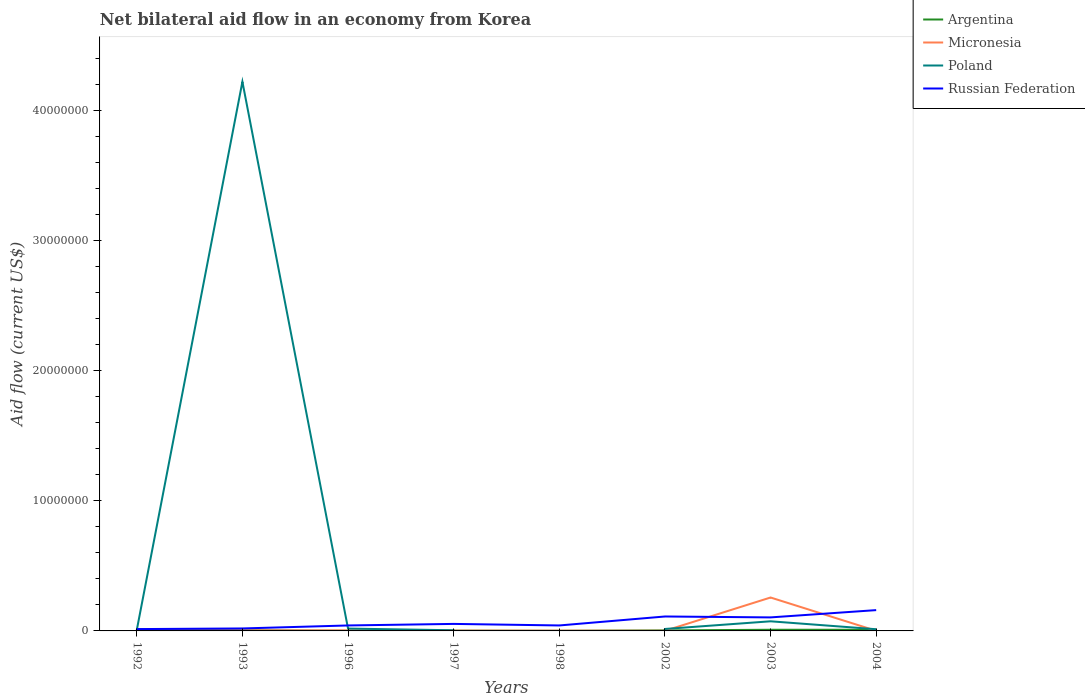How many different coloured lines are there?
Your answer should be very brief. 4. What is the total net bilateral aid flow in Poland in the graph?
Your response must be concise. 4.21e+07. What is the difference between the highest and the second highest net bilateral aid flow in Russian Federation?
Offer a terse response. 1.46e+06. What is the difference between the highest and the lowest net bilateral aid flow in Poland?
Provide a succinct answer. 1. What is the difference between two consecutive major ticks on the Y-axis?
Your answer should be compact. 1.00e+07. Where does the legend appear in the graph?
Give a very brief answer. Top right. What is the title of the graph?
Keep it short and to the point. Net bilateral aid flow in an economy from Korea. Does "Indonesia" appear as one of the legend labels in the graph?
Offer a very short reply. No. What is the Aid flow (current US$) of Argentina in 1992?
Provide a short and direct response. 1.20e+05. What is the Aid flow (current US$) of Micronesia in 1992?
Provide a succinct answer. 4.00e+04. What is the Aid flow (current US$) in Poland in 1992?
Keep it short and to the point. 7.00e+04. What is the Aid flow (current US$) in Russian Federation in 1992?
Offer a very short reply. 1.40e+05. What is the Aid flow (current US$) in Argentina in 1993?
Your answer should be compact. 5.00e+04. What is the Aid flow (current US$) of Poland in 1993?
Your answer should be very brief. 4.22e+07. What is the Aid flow (current US$) of Argentina in 1996?
Your answer should be compact. 10000. What is the Aid flow (current US$) in Micronesia in 1996?
Provide a short and direct response. 4.00e+04. What is the Aid flow (current US$) of Poland in 1996?
Ensure brevity in your answer.  1.80e+05. What is the Aid flow (current US$) of Russian Federation in 1996?
Provide a succinct answer. 4.20e+05. What is the Aid flow (current US$) in Argentina in 1997?
Your response must be concise. 2.00e+04. What is the Aid flow (current US$) of Micronesia in 1997?
Provide a short and direct response. 2.00e+04. What is the Aid flow (current US$) of Russian Federation in 1997?
Give a very brief answer. 5.40e+05. What is the Aid flow (current US$) of Argentina in 2002?
Provide a short and direct response. 4.00e+04. What is the Aid flow (current US$) in Micronesia in 2002?
Your response must be concise. 10000. What is the Aid flow (current US$) in Russian Federation in 2002?
Your answer should be very brief. 1.11e+06. What is the Aid flow (current US$) in Argentina in 2003?
Provide a short and direct response. 9.00e+04. What is the Aid flow (current US$) in Micronesia in 2003?
Your response must be concise. 2.57e+06. What is the Aid flow (current US$) in Poland in 2003?
Your answer should be very brief. 7.40e+05. What is the Aid flow (current US$) in Russian Federation in 2003?
Provide a short and direct response. 1.04e+06. What is the Aid flow (current US$) of Russian Federation in 2004?
Provide a succinct answer. 1.60e+06. Across all years, what is the maximum Aid flow (current US$) of Micronesia?
Offer a very short reply. 2.57e+06. Across all years, what is the maximum Aid flow (current US$) in Poland?
Your answer should be compact. 4.22e+07. Across all years, what is the maximum Aid flow (current US$) in Russian Federation?
Provide a short and direct response. 1.60e+06. Across all years, what is the minimum Aid flow (current US$) of Poland?
Keep it short and to the point. 0. What is the total Aid flow (current US$) of Argentina in the graph?
Provide a short and direct response. 4.30e+05. What is the total Aid flow (current US$) in Micronesia in the graph?
Offer a terse response. 2.75e+06. What is the total Aid flow (current US$) of Poland in the graph?
Provide a succinct answer. 4.36e+07. What is the total Aid flow (current US$) of Russian Federation in the graph?
Your answer should be compact. 5.46e+06. What is the difference between the Aid flow (current US$) of Argentina in 1992 and that in 1993?
Provide a short and direct response. 7.00e+04. What is the difference between the Aid flow (current US$) in Micronesia in 1992 and that in 1993?
Your answer should be very brief. 0. What is the difference between the Aid flow (current US$) in Poland in 1992 and that in 1993?
Make the answer very short. -4.22e+07. What is the difference between the Aid flow (current US$) in Russian Federation in 1992 and that in 1993?
Offer a terse response. -5.00e+04. What is the difference between the Aid flow (current US$) in Poland in 1992 and that in 1996?
Offer a very short reply. -1.10e+05. What is the difference between the Aid flow (current US$) of Russian Federation in 1992 and that in 1996?
Offer a very short reply. -2.80e+05. What is the difference between the Aid flow (current US$) in Argentina in 1992 and that in 1997?
Offer a very short reply. 1.00e+05. What is the difference between the Aid flow (current US$) in Poland in 1992 and that in 1997?
Offer a terse response. 2.00e+04. What is the difference between the Aid flow (current US$) in Russian Federation in 1992 and that in 1997?
Ensure brevity in your answer.  -4.00e+05. What is the difference between the Aid flow (current US$) in Argentina in 1992 and that in 1998?
Ensure brevity in your answer.  1.10e+05. What is the difference between the Aid flow (current US$) of Micronesia in 1992 and that in 1998?
Offer a very short reply. 2.00e+04. What is the difference between the Aid flow (current US$) of Russian Federation in 1992 and that in 1998?
Your answer should be compact. -2.80e+05. What is the difference between the Aid flow (current US$) in Micronesia in 1992 and that in 2002?
Provide a short and direct response. 3.00e+04. What is the difference between the Aid flow (current US$) of Russian Federation in 1992 and that in 2002?
Your answer should be compact. -9.70e+05. What is the difference between the Aid flow (current US$) of Argentina in 1992 and that in 2003?
Provide a short and direct response. 3.00e+04. What is the difference between the Aid flow (current US$) in Micronesia in 1992 and that in 2003?
Your answer should be very brief. -2.53e+06. What is the difference between the Aid flow (current US$) in Poland in 1992 and that in 2003?
Offer a very short reply. -6.70e+05. What is the difference between the Aid flow (current US$) in Russian Federation in 1992 and that in 2003?
Provide a succinct answer. -9.00e+05. What is the difference between the Aid flow (current US$) of Argentina in 1992 and that in 2004?
Make the answer very short. 3.00e+04. What is the difference between the Aid flow (current US$) of Russian Federation in 1992 and that in 2004?
Offer a very short reply. -1.46e+06. What is the difference between the Aid flow (current US$) of Argentina in 1993 and that in 1996?
Offer a very short reply. 4.00e+04. What is the difference between the Aid flow (current US$) of Poland in 1993 and that in 1996?
Give a very brief answer. 4.21e+07. What is the difference between the Aid flow (current US$) of Argentina in 1993 and that in 1997?
Ensure brevity in your answer.  3.00e+04. What is the difference between the Aid flow (current US$) of Micronesia in 1993 and that in 1997?
Offer a very short reply. 2.00e+04. What is the difference between the Aid flow (current US$) in Poland in 1993 and that in 1997?
Your answer should be very brief. 4.22e+07. What is the difference between the Aid flow (current US$) in Russian Federation in 1993 and that in 1997?
Provide a short and direct response. -3.50e+05. What is the difference between the Aid flow (current US$) of Argentina in 1993 and that in 1998?
Give a very brief answer. 4.00e+04. What is the difference between the Aid flow (current US$) of Russian Federation in 1993 and that in 1998?
Provide a succinct answer. -2.30e+05. What is the difference between the Aid flow (current US$) of Poland in 1993 and that in 2002?
Make the answer very short. 4.21e+07. What is the difference between the Aid flow (current US$) in Russian Federation in 1993 and that in 2002?
Your answer should be very brief. -9.20e+05. What is the difference between the Aid flow (current US$) of Micronesia in 1993 and that in 2003?
Provide a succinct answer. -2.53e+06. What is the difference between the Aid flow (current US$) of Poland in 1993 and that in 2003?
Provide a short and direct response. 4.15e+07. What is the difference between the Aid flow (current US$) in Russian Federation in 1993 and that in 2003?
Offer a terse response. -8.50e+05. What is the difference between the Aid flow (current US$) of Micronesia in 1993 and that in 2004?
Give a very brief answer. 3.00e+04. What is the difference between the Aid flow (current US$) of Poland in 1993 and that in 2004?
Offer a very short reply. 4.21e+07. What is the difference between the Aid flow (current US$) of Russian Federation in 1993 and that in 2004?
Give a very brief answer. -1.41e+06. What is the difference between the Aid flow (current US$) in Micronesia in 1996 and that in 1997?
Ensure brevity in your answer.  2.00e+04. What is the difference between the Aid flow (current US$) of Poland in 1996 and that in 1997?
Your response must be concise. 1.30e+05. What is the difference between the Aid flow (current US$) of Russian Federation in 1996 and that in 1998?
Offer a very short reply. 0. What is the difference between the Aid flow (current US$) in Poland in 1996 and that in 2002?
Provide a succinct answer. 3.00e+04. What is the difference between the Aid flow (current US$) in Russian Federation in 1996 and that in 2002?
Your answer should be very brief. -6.90e+05. What is the difference between the Aid flow (current US$) of Micronesia in 1996 and that in 2003?
Your answer should be compact. -2.53e+06. What is the difference between the Aid flow (current US$) of Poland in 1996 and that in 2003?
Offer a terse response. -5.60e+05. What is the difference between the Aid flow (current US$) of Russian Federation in 1996 and that in 2003?
Make the answer very short. -6.20e+05. What is the difference between the Aid flow (current US$) of Russian Federation in 1996 and that in 2004?
Your answer should be compact. -1.18e+06. What is the difference between the Aid flow (current US$) of Russian Federation in 1997 and that in 2002?
Make the answer very short. -5.70e+05. What is the difference between the Aid flow (current US$) in Argentina in 1997 and that in 2003?
Your answer should be very brief. -7.00e+04. What is the difference between the Aid flow (current US$) of Micronesia in 1997 and that in 2003?
Offer a terse response. -2.55e+06. What is the difference between the Aid flow (current US$) of Poland in 1997 and that in 2003?
Provide a succinct answer. -6.90e+05. What is the difference between the Aid flow (current US$) of Russian Federation in 1997 and that in 2003?
Your answer should be very brief. -5.00e+05. What is the difference between the Aid flow (current US$) of Argentina in 1997 and that in 2004?
Your answer should be very brief. -7.00e+04. What is the difference between the Aid flow (current US$) of Micronesia in 1997 and that in 2004?
Ensure brevity in your answer.  10000. What is the difference between the Aid flow (current US$) in Russian Federation in 1997 and that in 2004?
Give a very brief answer. -1.06e+06. What is the difference between the Aid flow (current US$) in Russian Federation in 1998 and that in 2002?
Give a very brief answer. -6.90e+05. What is the difference between the Aid flow (current US$) of Argentina in 1998 and that in 2003?
Offer a terse response. -8.00e+04. What is the difference between the Aid flow (current US$) of Micronesia in 1998 and that in 2003?
Give a very brief answer. -2.55e+06. What is the difference between the Aid flow (current US$) in Russian Federation in 1998 and that in 2003?
Provide a short and direct response. -6.20e+05. What is the difference between the Aid flow (current US$) in Argentina in 1998 and that in 2004?
Offer a terse response. -8.00e+04. What is the difference between the Aid flow (current US$) in Russian Federation in 1998 and that in 2004?
Your answer should be compact. -1.18e+06. What is the difference between the Aid flow (current US$) in Micronesia in 2002 and that in 2003?
Provide a short and direct response. -2.56e+06. What is the difference between the Aid flow (current US$) in Poland in 2002 and that in 2003?
Make the answer very short. -5.90e+05. What is the difference between the Aid flow (current US$) of Russian Federation in 2002 and that in 2003?
Provide a succinct answer. 7.00e+04. What is the difference between the Aid flow (current US$) in Russian Federation in 2002 and that in 2004?
Your answer should be compact. -4.90e+05. What is the difference between the Aid flow (current US$) of Argentina in 2003 and that in 2004?
Your answer should be very brief. 0. What is the difference between the Aid flow (current US$) of Micronesia in 2003 and that in 2004?
Your answer should be compact. 2.56e+06. What is the difference between the Aid flow (current US$) of Russian Federation in 2003 and that in 2004?
Keep it short and to the point. -5.60e+05. What is the difference between the Aid flow (current US$) of Argentina in 1992 and the Aid flow (current US$) of Micronesia in 1993?
Your response must be concise. 8.00e+04. What is the difference between the Aid flow (current US$) of Argentina in 1992 and the Aid flow (current US$) of Poland in 1993?
Provide a succinct answer. -4.21e+07. What is the difference between the Aid flow (current US$) of Micronesia in 1992 and the Aid flow (current US$) of Poland in 1993?
Keep it short and to the point. -4.22e+07. What is the difference between the Aid flow (current US$) in Micronesia in 1992 and the Aid flow (current US$) in Russian Federation in 1993?
Make the answer very short. -1.50e+05. What is the difference between the Aid flow (current US$) of Poland in 1992 and the Aid flow (current US$) of Russian Federation in 1993?
Your response must be concise. -1.20e+05. What is the difference between the Aid flow (current US$) of Argentina in 1992 and the Aid flow (current US$) of Micronesia in 1996?
Offer a very short reply. 8.00e+04. What is the difference between the Aid flow (current US$) in Argentina in 1992 and the Aid flow (current US$) in Poland in 1996?
Provide a succinct answer. -6.00e+04. What is the difference between the Aid flow (current US$) in Argentina in 1992 and the Aid flow (current US$) in Russian Federation in 1996?
Make the answer very short. -3.00e+05. What is the difference between the Aid flow (current US$) in Micronesia in 1992 and the Aid flow (current US$) in Poland in 1996?
Provide a short and direct response. -1.40e+05. What is the difference between the Aid flow (current US$) of Micronesia in 1992 and the Aid flow (current US$) of Russian Federation in 1996?
Your answer should be very brief. -3.80e+05. What is the difference between the Aid flow (current US$) in Poland in 1992 and the Aid flow (current US$) in Russian Federation in 1996?
Provide a succinct answer. -3.50e+05. What is the difference between the Aid flow (current US$) in Argentina in 1992 and the Aid flow (current US$) in Micronesia in 1997?
Keep it short and to the point. 1.00e+05. What is the difference between the Aid flow (current US$) in Argentina in 1992 and the Aid flow (current US$) in Russian Federation in 1997?
Offer a very short reply. -4.20e+05. What is the difference between the Aid flow (current US$) in Micronesia in 1992 and the Aid flow (current US$) in Poland in 1997?
Your answer should be compact. -10000. What is the difference between the Aid flow (current US$) in Micronesia in 1992 and the Aid flow (current US$) in Russian Federation in 1997?
Your response must be concise. -5.00e+05. What is the difference between the Aid flow (current US$) of Poland in 1992 and the Aid flow (current US$) of Russian Federation in 1997?
Make the answer very short. -4.70e+05. What is the difference between the Aid flow (current US$) in Argentina in 1992 and the Aid flow (current US$) in Micronesia in 1998?
Offer a very short reply. 1.00e+05. What is the difference between the Aid flow (current US$) in Argentina in 1992 and the Aid flow (current US$) in Russian Federation in 1998?
Your answer should be very brief. -3.00e+05. What is the difference between the Aid flow (current US$) in Micronesia in 1992 and the Aid flow (current US$) in Russian Federation in 1998?
Give a very brief answer. -3.80e+05. What is the difference between the Aid flow (current US$) of Poland in 1992 and the Aid flow (current US$) of Russian Federation in 1998?
Provide a short and direct response. -3.50e+05. What is the difference between the Aid flow (current US$) of Argentina in 1992 and the Aid flow (current US$) of Poland in 2002?
Ensure brevity in your answer.  -3.00e+04. What is the difference between the Aid flow (current US$) of Argentina in 1992 and the Aid flow (current US$) of Russian Federation in 2002?
Provide a succinct answer. -9.90e+05. What is the difference between the Aid flow (current US$) of Micronesia in 1992 and the Aid flow (current US$) of Russian Federation in 2002?
Keep it short and to the point. -1.07e+06. What is the difference between the Aid flow (current US$) in Poland in 1992 and the Aid flow (current US$) in Russian Federation in 2002?
Your answer should be very brief. -1.04e+06. What is the difference between the Aid flow (current US$) in Argentina in 1992 and the Aid flow (current US$) in Micronesia in 2003?
Give a very brief answer. -2.45e+06. What is the difference between the Aid flow (current US$) of Argentina in 1992 and the Aid flow (current US$) of Poland in 2003?
Your answer should be very brief. -6.20e+05. What is the difference between the Aid flow (current US$) in Argentina in 1992 and the Aid flow (current US$) in Russian Federation in 2003?
Your response must be concise. -9.20e+05. What is the difference between the Aid flow (current US$) in Micronesia in 1992 and the Aid flow (current US$) in Poland in 2003?
Make the answer very short. -7.00e+05. What is the difference between the Aid flow (current US$) of Poland in 1992 and the Aid flow (current US$) of Russian Federation in 2003?
Provide a short and direct response. -9.70e+05. What is the difference between the Aid flow (current US$) in Argentina in 1992 and the Aid flow (current US$) in Micronesia in 2004?
Your response must be concise. 1.10e+05. What is the difference between the Aid flow (current US$) of Argentina in 1992 and the Aid flow (current US$) of Poland in 2004?
Keep it short and to the point. -10000. What is the difference between the Aid flow (current US$) of Argentina in 1992 and the Aid flow (current US$) of Russian Federation in 2004?
Offer a very short reply. -1.48e+06. What is the difference between the Aid flow (current US$) of Micronesia in 1992 and the Aid flow (current US$) of Poland in 2004?
Your response must be concise. -9.00e+04. What is the difference between the Aid flow (current US$) in Micronesia in 1992 and the Aid flow (current US$) in Russian Federation in 2004?
Your answer should be compact. -1.56e+06. What is the difference between the Aid flow (current US$) of Poland in 1992 and the Aid flow (current US$) of Russian Federation in 2004?
Ensure brevity in your answer.  -1.53e+06. What is the difference between the Aid flow (current US$) in Argentina in 1993 and the Aid flow (current US$) in Poland in 1996?
Offer a very short reply. -1.30e+05. What is the difference between the Aid flow (current US$) in Argentina in 1993 and the Aid flow (current US$) in Russian Federation in 1996?
Your answer should be very brief. -3.70e+05. What is the difference between the Aid flow (current US$) of Micronesia in 1993 and the Aid flow (current US$) of Russian Federation in 1996?
Provide a succinct answer. -3.80e+05. What is the difference between the Aid flow (current US$) in Poland in 1993 and the Aid flow (current US$) in Russian Federation in 1996?
Offer a very short reply. 4.18e+07. What is the difference between the Aid flow (current US$) of Argentina in 1993 and the Aid flow (current US$) of Poland in 1997?
Make the answer very short. 0. What is the difference between the Aid flow (current US$) of Argentina in 1993 and the Aid flow (current US$) of Russian Federation in 1997?
Your response must be concise. -4.90e+05. What is the difference between the Aid flow (current US$) of Micronesia in 1993 and the Aid flow (current US$) of Poland in 1997?
Provide a short and direct response. -10000. What is the difference between the Aid flow (current US$) of Micronesia in 1993 and the Aid flow (current US$) of Russian Federation in 1997?
Make the answer very short. -5.00e+05. What is the difference between the Aid flow (current US$) in Poland in 1993 and the Aid flow (current US$) in Russian Federation in 1997?
Offer a terse response. 4.17e+07. What is the difference between the Aid flow (current US$) in Argentina in 1993 and the Aid flow (current US$) in Russian Federation in 1998?
Keep it short and to the point. -3.70e+05. What is the difference between the Aid flow (current US$) in Micronesia in 1993 and the Aid flow (current US$) in Russian Federation in 1998?
Keep it short and to the point. -3.80e+05. What is the difference between the Aid flow (current US$) in Poland in 1993 and the Aid flow (current US$) in Russian Federation in 1998?
Your response must be concise. 4.18e+07. What is the difference between the Aid flow (current US$) of Argentina in 1993 and the Aid flow (current US$) of Micronesia in 2002?
Give a very brief answer. 4.00e+04. What is the difference between the Aid flow (current US$) in Argentina in 1993 and the Aid flow (current US$) in Russian Federation in 2002?
Ensure brevity in your answer.  -1.06e+06. What is the difference between the Aid flow (current US$) of Micronesia in 1993 and the Aid flow (current US$) of Russian Federation in 2002?
Keep it short and to the point. -1.07e+06. What is the difference between the Aid flow (current US$) in Poland in 1993 and the Aid flow (current US$) in Russian Federation in 2002?
Ensure brevity in your answer.  4.11e+07. What is the difference between the Aid flow (current US$) in Argentina in 1993 and the Aid flow (current US$) in Micronesia in 2003?
Your answer should be compact. -2.52e+06. What is the difference between the Aid flow (current US$) in Argentina in 1993 and the Aid flow (current US$) in Poland in 2003?
Offer a very short reply. -6.90e+05. What is the difference between the Aid flow (current US$) in Argentina in 1993 and the Aid flow (current US$) in Russian Federation in 2003?
Provide a short and direct response. -9.90e+05. What is the difference between the Aid flow (current US$) in Micronesia in 1993 and the Aid flow (current US$) in Poland in 2003?
Provide a short and direct response. -7.00e+05. What is the difference between the Aid flow (current US$) of Poland in 1993 and the Aid flow (current US$) of Russian Federation in 2003?
Your answer should be very brief. 4.12e+07. What is the difference between the Aid flow (current US$) of Argentina in 1993 and the Aid flow (current US$) of Micronesia in 2004?
Ensure brevity in your answer.  4.00e+04. What is the difference between the Aid flow (current US$) in Argentina in 1993 and the Aid flow (current US$) in Russian Federation in 2004?
Offer a very short reply. -1.55e+06. What is the difference between the Aid flow (current US$) of Micronesia in 1993 and the Aid flow (current US$) of Poland in 2004?
Provide a short and direct response. -9.00e+04. What is the difference between the Aid flow (current US$) of Micronesia in 1993 and the Aid flow (current US$) of Russian Federation in 2004?
Keep it short and to the point. -1.56e+06. What is the difference between the Aid flow (current US$) of Poland in 1993 and the Aid flow (current US$) of Russian Federation in 2004?
Make the answer very short. 4.06e+07. What is the difference between the Aid flow (current US$) in Argentina in 1996 and the Aid flow (current US$) in Micronesia in 1997?
Make the answer very short. -10000. What is the difference between the Aid flow (current US$) in Argentina in 1996 and the Aid flow (current US$) in Russian Federation in 1997?
Ensure brevity in your answer.  -5.30e+05. What is the difference between the Aid flow (current US$) in Micronesia in 1996 and the Aid flow (current US$) in Russian Federation in 1997?
Your response must be concise. -5.00e+05. What is the difference between the Aid flow (current US$) in Poland in 1996 and the Aid flow (current US$) in Russian Federation in 1997?
Provide a succinct answer. -3.60e+05. What is the difference between the Aid flow (current US$) in Argentina in 1996 and the Aid flow (current US$) in Micronesia in 1998?
Your answer should be compact. -10000. What is the difference between the Aid flow (current US$) in Argentina in 1996 and the Aid flow (current US$) in Russian Federation in 1998?
Provide a succinct answer. -4.10e+05. What is the difference between the Aid flow (current US$) in Micronesia in 1996 and the Aid flow (current US$) in Russian Federation in 1998?
Your answer should be very brief. -3.80e+05. What is the difference between the Aid flow (current US$) in Poland in 1996 and the Aid flow (current US$) in Russian Federation in 1998?
Your response must be concise. -2.40e+05. What is the difference between the Aid flow (current US$) of Argentina in 1996 and the Aid flow (current US$) of Micronesia in 2002?
Make the answer very short. 0. What is the difference between the Aid flow (current US$) in Argentina in 1996 and the Aid flow (current US$) in Russian Federation in 2002?
Your response must be concise. -1.10e+06. What is the difference between the Aid flow (current US$) in Micronesia in 1996 and the Aid flow (current US$) in Russian Federation in 2002?
Provide a succinct answer. -1.07e+06. What is the difference between the Aid flow (current US$) of Poland in 1996 and the Aid flow (current US$) of Russian Federation in 2002?
Give a very brief answer. -9.30e+05. What is the difference between the Aid flow (current US$) of Argentina in 1996 and the Aid flow (current US$) of Micronesia in 2003?
Your response must be concise. -2.56e+06. What is the difference between the Aid flow (current US$) in Argentina in 1996 and the Aid flow (current US$) in Poland in 2003?
Your answer should be very brief. -7.30e+05. What is the difference between the Aid flow (current US$) in Argentina in 1996 and the Aid flow (current US$) in Russian Federation in 2003?
Your answer should be compact. -1.03e+06. What is the difference between the Aid flow (current US$) of Micronesia in 1996 and the Aid flow (current US$) of Poland in 2003?
Offer a very short reply. -7.00e+05. What is the difference between the Aid flow (current US$) of Poland in 1996 and the Aid flow (current US$) of Russian Federation in 2003?
Give a very brief answer. -8.60e+05. What is the difference between the Aid flow (current US$) of Argentina in 1996 and the Aid flow (current US$) of Russian Federation in 2004?
Ensure brevity in your answer.  -1.59e+06. What is the difference between the Aid flow (current US$) in Micronesia in 1996 and the Aid flow (current US$) in Poland in 2004?
Provide a succinct answer. -9.00e+04. What is the difference between the Aid flow (current US$) in Micronesia in 1996 and the Aid flow (current US$) in Russian Federation in 2004?
Provide a short and direct response. -1.56e+06. What is the difference between the Aid flow (current US$) of Poland in 1996 and the Aid flow (current US$) of Russian Federation in 2004?
Your response must be concise. -1.42e+06. What is the difference between the Aid flow (current US$) of Argentina in 1997 and the Aid flow (current US$) of Micronesia in 1998?
Ensure brevity in your answer.  0. What is the difference between the Aid flow (current US$) in Argentina in 1997 and the Aid flow (current US$) in Russian Federation in 1998?
Your response must be concise. -4.00e+05. What is the difference between the Aid flow (current US$) in Micronesia in 1997 and the Aid flow (current US$) in Russian Federation in 1998?
Ensure brevity in your answer.  -4.00e+05. What is the difference between the Aid flow (current US$) of Poland in 1997 and the Aid flow (current US$) of Russian Federation in 1998?
Keep it short and to the point. -3.70e+05. What is the difference between the Aid flow (current US$) of Argentina in 1997 and the Aid flow (current US$) of Micronesia in 2002?
Ensure brevity in your answer.  10000. What is the difference between the Aid flow (current US$) in Argentina in 1997 and the Aid flow (current US$) in Poland in 2002?
Keep it short and to the point. -1.30e+05. What is the difference between the Aid flow (current US$) in Argentina in 1997 and the Aid flow (current US$) in Russian Federation in 2002?
Offer a terse response. -1.09e+06. What is the difference between the Aid flow (current US$) in Micronesia in 1997 and the Aid flow (current US$) in Russian Federation in 2002?
Your response must be concise. -1.09e+06. What is the difference between the Aid flow (current US$) of Poland in 1997 and the Aid flow (current US$) of Russian Federation in 2002?
Keep it short and to the point. -1.06e+06. What is the difference between the Aid flow (current US$) in Argentina in 1997 and the Aid flow (current US$) in Micronesia in 2003?
Your answer should be very brief. -2.55e+06. What is the difference between the Aid flow (current US$) of Argentina in 1997 and the Aid flow (current US$) of Poland in 2003?
Offer a terse response. -7.20e+05. What is the difference between the Aid flow (current US$) of Argentina in 1997 and the Aid flow (current US$) of Russian Federation in 2003?
Your response must be concise. -1.02e+06. What is the difference between the Aid flow (current US$) of Micronesia in 1997 and the Aid flow (current US$) of Poland in 2003?
Offer a very short reply. -7.20e+05. What is the difference between the Aid flow (current US$) in Micronesia in 1997 and the Aid flow (current US$) in Russian Federation in 2003?
Ensure brevity in your answer.  -1.02e+06. What is the difference between the Aid flow (current US$) in Poland in 1997 and the Aid flow (current US$) in Russian Federation in 2003?
Provide a succinct answer. -9.90e+05. What is the difference between the Aid flow (current US$) in Argentina in 1997 and the Aid flow (current US$) in Russian Federation in 2004?
Offer a very short reply. -1.58e+06. What is the difference between the Aid flow (current US$) of Micronesia in 1997 and the Aid flow (current US$) of Russian Federation in 2004?
Provide a succinct answer. -1.58e+06. What is the difference between the Aid flow (current US$) of Poland in 1997 and the Aid flow (current US$) of Russian Federation in 2004?
Give a very brief answer. -1.55e+06. What is the difference between the Aid flow (current US$) in Argentina in 1998 and the Aid flow (current US$) in Poland in 2002?
Your answer should be very brief. -1.40e+05. What is the difference between the Aid flow (current US$) in Argentina in 1998 and the Aid flow (current US$) in Russian Federation in 2002?
Give a very brief answer. -1.10e+06. What is the difference between the Aid flow (current US$) of Micronesia in 1998 and the Aid flow (current US$) of Poland in 2002?
Provide a succinct answer. -1.30e+05. What is the difference between the Aid flow (current US$) of Micronesia in 1998 and the Aid flow (current US$) of Russian Federation in 2002?
Your answer should be compact. -1.09e+06. What is the difference between the Aid flow (current US$) in Argentina in 1998 and the Aid flow (current US$) in Micronesia in 2003?
Ensure brevity in your answer.  -2.56e+06. What is the difference between the Aid flow (current US$) of Argentina in 1998 and the Aid flow (current US$) of Poland in 2003?
Make the answer very short. -7.30e+05. What is the difference between the Aid flow (current US$) of Argentina in 1998 and the Aid flow (current US$) of Russian Federation in 2003?
Provide a succinct answer. -1.03e+06. What is the difference between the Aid flow (current US$) in Micronesia in 1998 and the Aid flow (current US$) in Poland in 2003?
Offer a very short reply. -7.20e+05. What is the difference between the Aid flow (current US$) in Micronesia in 1998 and the Aid flow (current US$) in Russian Federation in 2003?
Give a very brief answer. -1.02e+06. What is the difference between the Aid flow (current US$) in Argentina in 1998 and the Aid flow (current US$) in Russian Federation in 2004?
Offer a terse response. -1.59e+06. What is the difference between the Aid flow (current US$) in Micronesia in 1998 and the Aid flow (current US$) in Russian Federation in 2004?
Ensure brevity in your answer.  -1.58e+06. What is the difference between the Aid flow (current US$) of Argentina in 2002 and the Aid flow (current US$) of Micronesia in 2003?
Ensure brevity in your answer.  -2.53e+06. What is the difference between the Aid flow (current US$) of Argentina in 2002 and the Aid flow (current US$) of Poland in 2003?
Your answer should be very brief. -7.00e+05. What is the difference between the Aid flow (current US$) in Argentina in 2002 and the Aid flow (current US$) in Russian Federation in 2003?
Ensure brevity in your answer.  -1.00e+06. What is the difference between the Aid flow (current US$) of Micronesia in 2002 and the Aid flow (current US$) of Poland in 2003?
Your answer should be very brief. -7.30e+05. What is the difference between the Aid flow (current US$) in Micronesia in 2002 and the Aid flow (current US$) in Russian Federation in 2003?
Offer a very short reply. -1.03e+06. What is the difference between the Aid flow (current US$) of Poland in 2002 and the Aid flow (current US$) of Russian Federation in 2003?
Provide a short and direct response. -8.90e+05. What is the difference between the Aid flow (current US$) in Argentina in 2002 and the Aid flow (current US$) in Russian Federation in 2004?
Your response must be concise. -1.56e+06. What is the difference between the Aid flow (current US$) of Micronesia in 2002 and the Aid flow (current US$) of Russian Federation in 2004?
Your answer should be very brief. -1.59e+06. What is the difference between the Aid flow (current US$) in Poland in 2002 and the Aid flow (current US$) in Russian Federation in 2004?
Provide a short and direct response. -1.45e+06. What is the difference between the Aid flow (current US$) of Argentina in 2003 and the Aid flow (current US$) of Micronesia in 2004?
Your answer should be very brief. 8.00e+04. What is the difference between the Aid flow (current US$) of Argentina in 2003 and the Aid flow (current US$) of Poland in 2004?
Provide a short and direct response. -4.00e+04. What is the difference between the Aid flow (current US$) in Argentina in 2003 and the Aid flow (current US$) in Russian Federation in 2004?
Provide a succinct answer. -1.51e+06. What is the difference between the Aid flow (current US$) of Micronesia in 2003 and the Aid flow (current US$) of Poland in 2004?
Offer a very short reply. 2.44e+06. What is the difference between the Aid flow (current US$) in Micronesia in 2003 and the Aid flow (current US$) in Russian Federation in 2004?
Make the answer very short. 9.70e+05. What is the difference between the Aid flow (current US$) of Poland in 2003 and the Aid flow (current US$) of Russian Federation in 2004?
Keep it short and to the point. -8.60e+05. What is the average Aid flow (current US$) in Argentina per year?
Your response must be concise. 5.38e+04. What is the average Aid flow (current US$) in Micronesia per year?
Your answer should be very brief. 3.44e+05. What is the average Aid flow (current US$) in Poland per year?
Provide a succinct answer. 5.44e+06. What is the average Aid flow (current US$) in Russian Federation per year?
Your answer should be very brief. 6.82e+05. In the year 1992, what is the difference between the Aid flow (current US$) in Argentina and Aid flow (current US$) in Poland?
Provide a succinct answer. 5.00e+04. In the year 1992, what is the difference between the Aid flow (current US$) of Argentina and Aid flow (current US$) of Russian Federation?
Your answer should be compact. -2.00e+04. In the year 1992, what is the difference between the Aid flow (current US$) in Micronesia and Aid flow (current US$) in Poland?
Make the answer very short. -3.00e+04. In the year 1992, what is the difference between the Aid flow (current US$) of Micronesia and Aid flow (current US$) of Russian Federation?
Give a very brief answer. -1.00e+05. In the year 1993, what is the difference between the Aid flow (current US$) in Argentina and Aid flow (current US$) in Micronesia?
Your answer should be very brief. 10000. In the year 1993, what is the difference between the Aid flow (current US$) in Argentina and Aid flow (current US$) in Poland?
Your response must be concise. -4.22e+07. In the year 1993, what is the difference between the Aid flow (current US$) of Micronesia and Aid flow (current US$) of Poland?
Your answer should be very brief. -4.22e+07. In the year 1993, what is the difference between the Aid flow (current US$) in Poland and Aid flow (current US$) in Russian Federation?
Offer a terse response. 4.20e+07. In the year 1996, what is the difference between the Aid flow (current US$) of Argentina and Aid flow (current US$) of Micronesia?
Your answer should be compact. -3.00e+04. In the year 1996, what is the difference between the Aid flow (current US$) in Argentina and Aid flow (current US$) in Poland?
Keep it short and to the point. -1.70e+05. In the year 1996, what is the difference between the Aid flow (current US$) in Argentina and Aid flow (current US$) in Russian Federation?
Give a very brief answer. -4.10e+05. In the year 1996, what is the difference between the Aid flow (current US$) in Micronesia and Aid flow (current US$) in Russian Federation?
Make the answer very short. -3.80e+05. In the year 1996, what is the difference between the Aid flow (current US$) in Poland and Aid flow (current US$) in Russian Federation?
Your answer should be compact. -2.40e+05. In the year 1997, what is the difference between the Aid flow (current US$) of Argentina and Aid flow (current US$) of Poland?
Your answer should be compact. -3.00e+04. In the year 1997, what is the difference between the Aid flow (current US$) in Argentina and Aid flow (current US$) in Russian Federation?
Make the answer very short. -5.20e+05. In the year 1997, what is the difference between the Aid flow (current US$) in Micronesia and Aid flow (current US$) in Russian Federation?
Your answer should be very brief. -5.20e+05. In the year 1997, what is the difference between the Aid flow (current US$) of Poland and Aid flow (current US$) of Russian Federation?
Your answer should be compact. -4.90e+05. In the year 1998, what is the difference between the Aid flow (current US$) of Argentina and Aid flow (current US$) of Micronesia?
Make the answer very short. -10000. In the year 1998, what is the difference between the Aid flow (current US$) of Argentina and Aid flow (current US$) of Russian Federation?
Your answer should be compact. -4.10e+05. In the year 1998, what is the difference between the Aid flow (current US$) in Micronesia and Aid flow (current US$) in Russian Federation?
Your response must be concise. -4.00e+05. In the year 2002, what is the difference between the Aid flow (current US$) of Argentina and Aid flow (current US$) of Micronesia?
Your response must be concise. 3.00e+04. In the year 2002, what is the difference between the Aid flow (current US$) of Argentina and Aid flow (current US$) of Poland?
Offer a terse response. -1.10e+05. In the year 2002, what is the difference between the Aid flow (current US$) of Argentina and Aid flow (current US$) of Russian Federation?
Keep it short and to the point. -1.07e+06. In the year 2002, what is the difference between the Aid flow (current US$) of Micronesia and Aid flow (current US$) of Russian Federation?
Offer a terse response. -1.10e+06. In the year 2002, what is the difference between the Aid flow (current US$) of Poland and Aid flow (current US$) of Russian Federation?
Provide a succinct answer. -9.60e+05. In the year 2003, what is the difference between the Aid flow (current US$) in Argentina and Aid flow (current US$) in Micronesia?
Provide a short and direct response. -2.48e+06. In the year 2003, what is the difference between the Aid flow (current US$) in Argentina and Aid flow (current US$) in Poland?
Provide a short and direct response. -6.50e+05. In the year 2003, what is the difference between the Aid flow (current US$) of Argentina and Aid flow (current US$) of Russian Federation?
Give a very brief answer. -9.50e+05. In the year 2003, what is the difference between the Aid flow (current US$) in Micronesia and Aid flow (current US$) in Poland?
Your answer should be compact. 1.83e+06. In the year 2003, what is the difference between the Aid flow (current US$) in Micronesia and Aid flow (current US$) in Russian Federation?
Offer a terse response. 1.53e+06. In the year 2004, what is the difference between the Aid flow (current US$) of Argentina and Aid flow (current US$) of Russian Federation?
Ensure brevity in your answer.  -1.51e+06. In the year 2004, what is the difference between the Aid flow (current US$) in Micronesia and Aid flow (current US$) in Russian Federation?
Provide a short and direct response. -1.59e+06. In the year 2004, what is the difference between the Aid flow (current US$) in Poland and Aid flow (current US$) in Russian Federation?
Provide a short and direct response. -1.47e+06. What is the ratio of the Aid flow (current US$) of Micronesia in 1992 to that in 1993?
Provide a succinct answer. 1. What is the ratio of the Aid flow (current US$) in Poland in 1992 to that in 1993?
Offer a very short reply. 0. What is the ratio of the Aid flow (current US$) of Russian Federation in 1992 to that in 1993?
Ensure brevity in your answer.  0.74. What is the ratio of the Aid flow (current US$) in Poland in 1992 to that in 1996?
Ensure brevity in your answer.  0.39. What is the ratio of the Aid flow (current US$) in Argentina in 1992 to that in 1997?
Keep it short and to the point. 6. What is the ratio of the Aid flow (current US$) in Russian Federation in 1992 to that in 1997?
Ensure brevity in your answer.  0.26. What is the ratio of the Aid flow (current US$) of Argentina in 1992 to that in 1998?
Offer a terse response. 12. What is the ratio of the Aid flow (current US$) of Poland in 1992 to that in 2002?
Provide a short and direct response. 0.47. What is the ratio of the Aid flow (current US$) in Russian Federation in 1992 to that in 2002?
Provide a short and direct response. 0.13. What is the ratio of the Aid flow (current US$) of Micronesia in 1992 to that in 2003?
Provide a succinct answer. 0.02. What is the ratio of the Aid flow (current US$) of Poland in 1992 to that in 2003?
Provide a succinct answer. 0.09. What is the ratio of the Aid flow (current US$) of Russian Federation in 1992 to that in 2003?
Offer a terse response. 0.13. What is the ratio of the Aid flow (current US$) in Poland in 1992 to that in 2004?
Your answer should be very brief. 0.54. What is the ratio of the Aid flow (current US$) of Russian Federation in 1992 to that in 2004?
Your response must be concise. 0.09. What is the ratio of the Aid flow (current US$) in Argentina in 1993 to that in 1996?
Your response must be concise. 5. What is the ratio of the Aid flow (current US$) in Poland in 1993 to that in 1996?
Your answer should be very brief. 234.67. What is the ratio of the Aid flow (current US$) of Russian Federation in 1993 to that in 1996?
Provide a short and direct response. 0.45. What is the ratio of the Aid flow (current US$) of Argentina in 1993 to that in 1997?
Make the answer very short. 2.5. What is the ratio of the Aid flow (current US$) in Poland in 1993 to that in 1997?
Keep it short and to the point. 844.8. What is the ratio of the Aid flow (current US$) in Russian Federation in 1993 to that in 1997?
Provide a short and direct response. 0.35. What is the ratio of the Aid flow (current US$) of Argentina in 1993 to that in 1998?
Provide a short and direct response. 5. What is the ratio of the Aid flow (current US$) of Micronesia in 1993 to that in 1998?
Your answer should be compact. 2. What is the ratio of the Aid flow (current US$) of Russian Federation in 1993 to that in 1998?
Your response must be concise. 0.45. What is the ratio of the Aid flow (current US$) of Micronesia in 1993 to that in 2002?
Offer a very short reply. 4. What is the ratio of the Aid flow (current US$) of Poland in 1993 to that in 2002?
Your answer should be compact. 281.6. What is the ratio of the Aid flow (current US$) of Russian Federation in 1993 to that in 2002?
Make the answer very short. 0.17. What is the ratio of the Aid flow (current US$) of Argentina in 1993 to that in 2003?
Your answer should be compact. 0.56. What is the ratio of the Aid flow (current US$) in Micronesia in 1993 to that in 2003?
Provide a short and direct response. 0.02. What is the ratio of the Aid flow (current US$) of Poland in 1993 to that in 2003?
Give a very brief answer. 57.08. What is the ratio of the Aid flow (current US$) in Russian Federation in 1993 to that in 2003?
Make the answer very short. 0.18. What is the ratio of the Aid flow (current US$) of Argentina in 1993 to that in 2004?
Your response must be concise. 0.56. What is the ratio of the Aid flow (current US$) in Poland in 1993 to that in 2004?
Offer a terse response. 324.92. What is the ratio of the Aid flow (current US$) of Russian Federation in 1993 to that in 2004?
Your answer should be compact. 0.12. What is the ratio of the Aid flow (current US$) in Micronesia in 1996 to that in 1997?
Give a very brief answer. 2. What is the ratio of the Aid flow (current US$) of Russian Federation in 1996 to that in 1997?
Provide a succinct answer. 0.78. What is the ratio of the Aid flow (current US$) in Argentina in 1996 to that in 1998?
Keep it short and to the point. 1. What is the ratio of the Aid flow (current US$) of Micronesia in 1996 to that in 1998?
Keep it short and to the point. 2. What is the ratio of the Aid flow (current US$) in Russian Federation in 1996 to that in 1998?
Provide a succinct answer. 1. What is the ratio of the Aid flow (current US$) in Micronesia in 1996 to that in 2002?
Your answer should be very brief. 4. What is the ratio of the Aid flow (current US$) of Poland in 1996 to that in 2002?
Your answer should be very brief. 1.2. What is the ratio of the Aid flow (current US$) of Russian Federation in 1996 to that in 2002?
Make the answer very short. 0.38. What is the ratio of the Aid flow (current US$) in Argentina in 1996 to that in 2003?
Your response must be concise. 0.11. What is the ratio of the Aid flow (current US$) in Micronesia in 1996 to that in 2003?
Offer a terse response. 0.02. What is the ratio of the Aid flow (current US$) in Poland in 1996 to that in 2003?
Offer a very short reply. 0.24. What is the ratio of the Aid flow (current US$) of Russian Federation in 1996 to that in 2003?
Your response must be concise. 0.4. What is the ratio of the Aid flow (current US$) in Argentina in 1996 to that in 2004?
Your answer should be compact. 0.11. What is the ratio of the Aid flow (current US$) in Micronesia in 1996 to that in 2004?
Your answer should be compact. 4. What is the ratio of the Aid flow (current US$) of Poland in 1996 to that in 2004?
Your answer should be compact. 1.38. What is the ratio of the Aid flow (current US$) in Russian Federation in 1996 to that in 2004?
Your answer should be compact. 0.26. What is the ratio of the Aid flow (current US$) of Russian Federation in 1997 to that in 1998?
Give a very brief answer. 1.29. What is the ratio of the Aid flow (current US$) in Argentina in 1997 to that in 2002?
Make the answer very short. 0.5. What is the ratio of the Aid flow (current US$) of Micronesia in 1997 to that in 2002?
Your answer should be compact. 2. What is the ratio of the Aid flow (current US$) of Poland in 1997 to that in 2002?
Give a very brief answer. 0.33. What is the ratio of the Aid flow (current US$) in Russian Federation in 1997 to that in 2002?
Offer a terse response. 0.49. What is the ratio of the Aid flow (current US$) of Argentina in 1997 to that in 2003?
Your response must be concise. 0.22. What is the ratio of the Aid flow (current US$) of Micronesia in 1997 to that in 2003?
Make the answer very short. 0.01. What is the ratio of the Aid flow (current US$) of Poland in 1997 to that in 2003?
Provide a short and direct response. 0.07. What is the ratio of the Aid flow (current US$) in Russian Federation in 1997 to that in 2003?
Your response must be concise. 0.52. What is the ratio of the Aid flow (current US$) in Argentina in 1997 to that in 2004?
Your response must be concise. 0.22. What is the ratio of the Aid flow (current US$) in Micronesia in 1997 to that in 2004?
Provide a succinct answer. 2. What is the ratio of the Aid flow (current US$) of Poland in 1997 to that in 2004?
Provide a short and direct response. 0.38. What is the ratio of the Aid flow (current US$) in Russian Federation in 1997 to that in 2004?
Give a very brief answer. 0.34. What is the ratio of the Aid flow (current US$) of Argentina in 1998 to that in 2002?
Provide a short and direct response. 0.25. What is the ratio of the Aid flow (current US$) of Micronesia in 1998 to that in 2002?
Your answer should be very brief. 2. What is the ratio of the Aid flow (current US$) in Russian Federation in 1998 to that in 2002?
Provide a short and direct response. 0.38. What is the ratio of the Aid flow (current US$) in Argentina in 1998 to that in 2003?
Ensure brevity in your answer.  0.11. What is the ratio of the Aid flow (current US$) in Micronesia in 1998 to that in 2003?
Give a very brief answer. 0.01. What is the ratio of the Aid flow (current US$) of Russian Federation in 1998 to that in 2003?
Offer a very short reply. 0.4. What is the ratio of the Aid flow (current US$) of Argentina in 1998 to that in 2004?
Provide a succinct answer. 0.11. What is the ratio of the Aid flow (current US$) of Russian Federation in 1998 to that in 2004?
Provide a succinct answer. 0.26. What is the ratio of the Aid flow (current US$) in Argentina in 2002 to that in 2003?
Provide a short and direct response. 0.44. What is the ratio of the Aid flow (current US$) in Micronesia in 2002 to that in 2003?
Keep it short and to the point. 0. What is the ratio of the Aid flow (current US$) in Poland in 2002 to that in 2003?
Your response must be concise. 0.2. What is the ratio of the Aid flow (current US$) of Russian Federation in 2002 to that in 2003?
Make the answer very short. 1.07. What is the ratio of the Aid flow (current US$) of Argentina in 2002 to that in 2004?
Keep it short and to the point. 0.44. What is the ratio of the Aid flow (current US$) of Micronesia in 2002 to that in 2004?
Give a very brief answer. 1. What is the ratio of the Aid flow (current US$) of Poland in 2002 to that in 2004?
Give a very brief answer. 1.15. What is the ratio of the Aid flow (current US$) of Russian Federation in 2002 to that in 2004?
Keep it short and to the point. 0.69. What is the ratio of the Aid flow (current US$) in Argentina in 2003 to that in 2004?
Your answer should be compact. 1. What is the ratio of the Aid flow (current US$) in Micronesia in 2003 to that in 2004?
Provide a short and direct response. 257. What is the ratio of the Aid flow (current US$) of Poland in 2003 to that in 2004?
Your answer should be very brief. 5.69. What is the ratio of the Aid flow (current US$) of Russian Federation in 2003 to that in 2004?
Offer a very short reply. 0.65. What is the difference between the highest and the second highest Aid flow (current US$) in Argentina?
Your answer should be compact. 3.00e+04. What is the difference between the highest and the second highest Aid flow (current US$) of Micronesia?
Ensure brevity in your answer.  2.53e+06. What is the difference between the highest and the second highest Aid flow (current US$) of Poland?
Offer a very short reply. 4.15e+07. What is the difference between the highest and the lowest Aid flow (current US$) in Micronesia?
Make the answer very short. 2.56e+06. What is the difference between the highest and the lowest Aid flow (current US$) in Poland?
Keep it short and to the point. 4.22e+07. What is the difference between the highest and the lowest Aid flow (current US$) of Russian Federation?
Make the answer very short. 1.46e+06. 